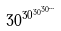Convert formula to latex. <formula><loc_0><loc_0><loc_500><loc_500>3 0 ^ { 3 0 ^ { 3 0 ^ { 3 0 ^ { \dots } } } }</formula> 